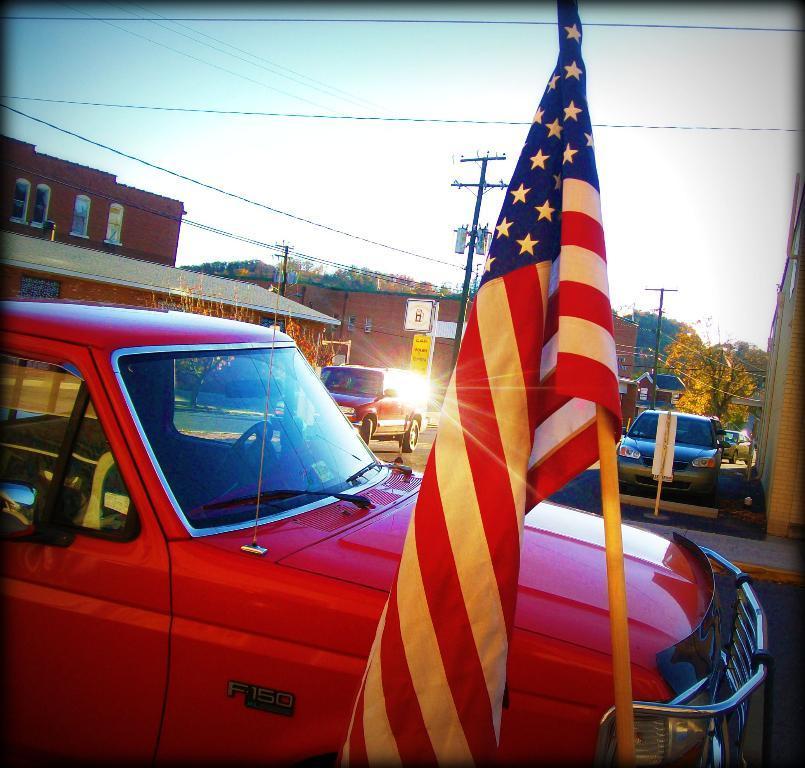Please provide a concise description of this image. In the picture there are two cars parked beside the road and in front of the first car there is an american flag and behind that car there is another vehicle moving on the road,behind the vehicle there are few houses and there are some poles beside the road and to the poles many wires are attached. In the background there are plenty of trees and sky. 